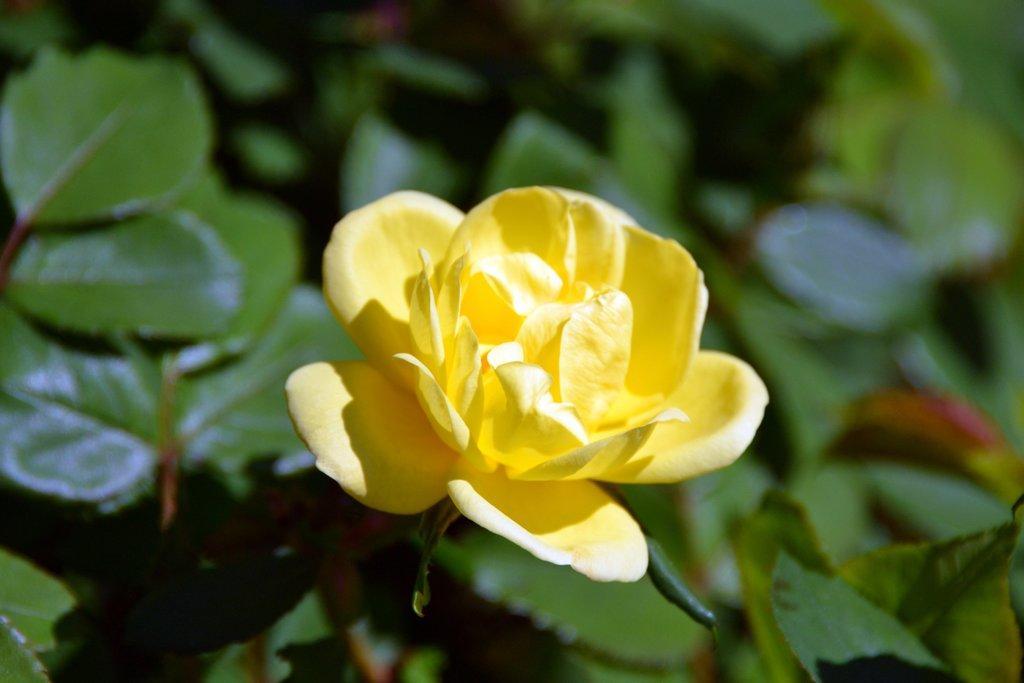Describe this image in one or two sentences. In this picture we can see a flower and in the background we can see leaves. 